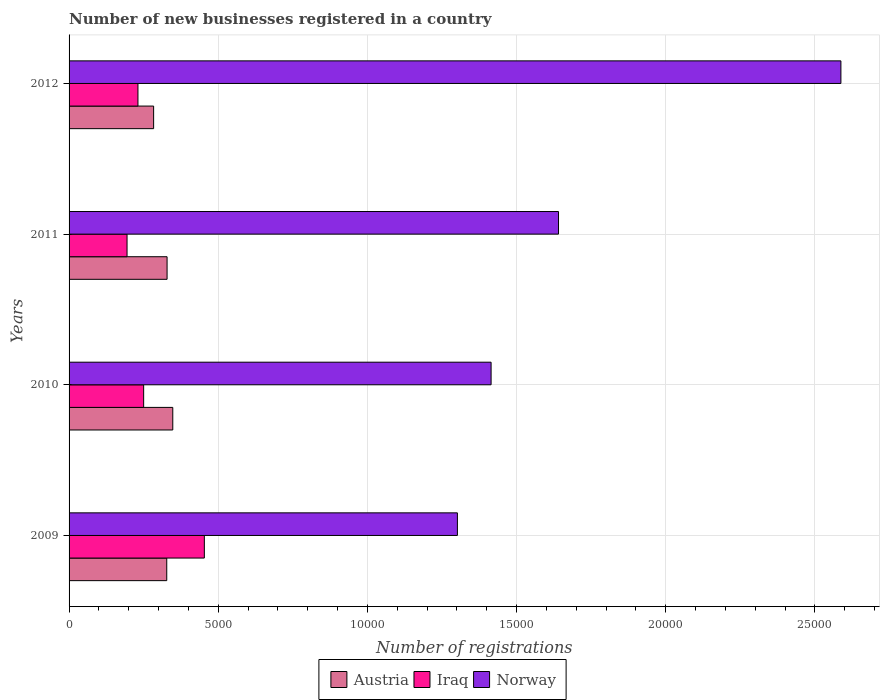How many different coloured bars are there?
Provide a succinct answer. 3. How many groups of bars are there?
Your answer should be compact. 4. Are the number of bars per tick equal to the number of legend labels?
Offer a very short reply. Yes. How many bars are there on the 4th tick from the top?
Make the answer very short. 3. How many bars are there on the 2nd tick from the bottom?
Keep it short and to the point. 3. What is the number of new businesses registered in Norway in 2010?
Your answer should be very brief. 1.41e+04. Across all years, what is the maximum number of new businesses registered in Norway?
Give a very brief answer. 2.59e+04. Across all years, what is the minimum number of new businesses registered in Norway?
Offer a terse response. 1.30e+04. In which year was the number of new businesses registered in Austria minimum?
Your response must be concise. 2012. What is the total number of new businesses registered in Iraq in the graph?
Provide a succinct answer. 1.13e+04. What is the difference between the number of new businesses registered in Iraq in 2009 and that in 2012?
Offer a terse response. 2225. What is the difference between the number of new businesses registered in Norway in 2010 and the number of new businesses registered in Iraq in 2009?
Make the answer very short. 9611. What is the average number of new businesses registered in Norway per year?
Make the answer very short. 1.74e+04. In the year 2009, what is the difference between the number of new businesses registered in Austria and number of new businesses registered in Iraq?
Provide a succinct answer. -1260. In how many years, is the number of new businesses registered in Iraq greater than 2000 ?
Provide a succinct answer. 3. What is the ratio of the number of new businesses registered in Norway in 2009 to that in 2012?
Offer a very short reply. 0.5. What is the difference between the highest and the second highest number of new businesses registered in Iraq?
Keep it short and to the point. 2034. What is the difference between the highest and the lowest number of new businesses registered in Norway?
Your answer should be compact. 1.29e+04. In how many years, is the number of new businesses registered in Norway greater than the average number of new businesses registered in Norway taken over all years?
Your answer should be very brief. 1. Is the sum of the number of new businesses registered in Iraq in 2010 and 2011 greater than the maximum number of new businesses registered in Austria across all years?
Your response must be concise. Yes. What does the 3rd bar from the top in 2012 represents?
Your response must be concise. Austria. What is the difference between two consecutive major ticks on the X-axis?
Your answer should be very brief. 5000. Are the values on the major ticks of X-axis written in scientific E-notation?
Ensure brevity in your answer.  No. Does the graph contain any zero values?
Your answer should be very brief. No. Where does the legend appear in the graph?
Your answer should be compact. Bottom center. How are the legend labels stacked?
Give a very brief answer. Horizontal. What is the title of the graph?
Offer a terse response. Number of new businesses registered in a country. Does "Sudan" appear as one of the legend labels in the graph?
Your answer should be compact. No. What is the label or title of the X-axis?
Offer a very short reply. Number of registrations. What is the label or title of the Y-axis?
Ensure brevity in your answer.  Years. What is the Number of registrations in Austria in 2009?
Provide a succinct answer. 3274. What is the Number of registrations in Iraq in 2009?
Your answer should be compact. 4534. What is the Number of registrations in Norway in 2009?
Keep it short and to the point. 1.30e+04. What is the Number of registrations in Austria in 2010?
Your response must be concise. 3476. What is the Number of registrations in Iraq in 2010?
Give a very brief answer. 2500. What is the Number of registrations of Norway in 2010?
Ensure brevity in your answer.  1.41e+04. What is the Number of registrations of Austria in 2011?
Your response must be concise. 3285. What is the Number of registrations in Iraq in 2011?
Provide a short and direct response. 1943. What is the Number of registrations in Norway in 2011?
Keep it short and to the point. 1.64e+04. What is the Number of registrations in Austria in 2012?
Provide a succinct answer. 2834. What is the Number of registrations in Iraq in 2012?
Keep it short and to the point. 2309. What is the Number of registrations of Norway in 2012?
Offer a terse response. 2.59e+04. Across all years, what is the maximum Number of registrations of Austria?
Your answer should be compact. 3476. Across all years, what is the maximum Number of registrations of Iraq?
Ensure brevity in your answer.  4534. Across all years, what is the maximum Number of registrations of Norway?
Keep it short and to the point. 2.59e+04. Across all years, what is the minimum Number of registrations of Austria?
Provide a succinct answer. 2834. Across all years, what is the minimum Number of registrations of Iraq?
Offer a very short reply. 1943. Across all years, what is the minimum Number of registrations of Norway?
Offer a terse response. 1.30e+04. What is the total Number of registrations in Austria in the graph?
Your response must be concise. 1.29e+04. What is the total Number of registrations in Iraq in the graph?
Make the answer very short. 1.13e+04. What is the total Number of registrations in Norway in the graph?
Offer a terse response. 6.94e+04. What is the difference between the Number of registrations of Austria in 2009 and that in 2010?
Offer a very short reply. -202. What is the difference between the Number of registrations of Iraq in 2009 and that in 2010?
Give a very brief answer. 2034. What is the difference between the Number of registrations in Norway in 2009 and that in 2010?
Give a very brief answer. -1129. What is the difference between the Number of registrations in Austria in 2009 and that in 2011?
Make the answer very short. -11. What is the difference between the Number of registrations of Iraq in 2009 and that in 2011?
Your answer should be compact. 2591. What is the difference between the Number of registrations of Norway in 2009 and that in 2011?
Provide a short and direct response. -3389. What is the difference between the Number of registrations in Austria in 2009 and that in 2012?
Make the answer very short. 440. What is the difference between the Number of registrations of Iraq in 2009 and that in 2012?
Keep it short and to the point. 2225. What is the difference between the Number of registrations of Norway in 2009 and that in 2012?
Offer a very short reply. -1.29e+04. What is the difference between the Number of registrations of Austria in 2010 and that in 2011?
Your answer should be compact. 191. What is the difference between the Number of registrations of Iraq in 2010 and that in 2011?
Your response must be concise. 557. What is the difference between the Number of registrations of Norway in 2010 and that in 2011?
Keep it short and to the point. -2260. What is the difference between the Number of registrations in Austria in 2010 and that in 2012?
Offer a terse response. 642. What is the difference between the Number of registrations of Iraq in 2010 and that in 2012?
Your answer should be compact. 191. What is the difference between the Number of registrations in Norway in 2010 and that in 2012?
Your answer should be compact. -1.17e+04. What is the difference between the Number of registrations of Austria in 2011 and that in 2012?
Give a very brief answer. 451. What is the difference between the Number of registrations of Iraq in 2011 and that in 2012?
Offer a very short reply. -366. What is the difference between the Number of registrations in Norway in 2011 and that in 2012?
Make the answer very short. -9465. What is the difference between the Number of registrations of Austria in 2009 and the Number of registrations of Iraq in 2010?
Your answer should be very brief. 774. What is the difference between the Number of registrations of Austria in 2009 and the Number of registrations of Norway in 2010?
Your response must be concise. -1.09e+04. What is the difference between the Number of registrations in Iraq in 2009 and the Number of registrations in Norway in 2010?
Provide a short and direct response. -9611. What is the difference between the Number of registrations of Austria in 2009 and the Number of registrations of Iraq in 2011?
Your answer should be very brief. 1331. What is the difference between the Number of registrations in Austria in 2009 and the Number of registrations in Norway in 2011?
Keep it short and to the point. -1.31e+04. What is the difference between the Number of registrations in Iraq in 2009 and the Number of registrations in Norway in 2011?
Your answer should be compact. -1.19e+04. What is the difference between the Number of registrations in Austria in 2009 and the Number of registrations in Iraq in 2012?
Ensure brevity in your answer.  965. What is the difference between the Number of registrations of Austria in 2009 and the Number of registrations of Norway in 2012?
Your answer should be compact. -2.26e+04. What is the difference between the Number of registrations of Iraq in 2009 and the Number of registrations of Norway in 2012?
Your response must be concise. -2.13e+04. What is the difference between the Number of registrations of Austria in 2010 and the Number of registrations of Iraq in 2011?
Provide a succinct answer. 1533. What is the difference between the Number of registrations in Austria in 2010 and the Number of registrations in Norway in 2011?
Provide a succinct answer. -1.29e+04. What is the difference between the Number of registrations in Iraq in 2010 and the Number of registrations in Norway in 2011?
Offer a terse response. -1.39e+04. What is the difference between the Number of registrations of Austria in 2010 and the Number of registrations of Iraq in 2012?
Offer a terse response. 1167. What is the difference between the Number of registrations of Austria in 2010 and the Number of registrations of Norway in 2012?
Make the answer very short. -2.24e+04. What is the difference between the Number of registrations of Iraq in 2010 and the Number of registrations of Norway in 2012?
Give a very brief answer. -2.34e+04. What is the difference between the Number of registrations of Austria in 2011 and the Number of registrations of Iraq in 2012?
Offer a terse response. 976. What is the difference between the Number of registrations of Austria in 2011 and the Number of registrations of Norway in 2012?
Your answer should be very brief. -2.26e+04. What is the difference between the Number of registrations of Iraq in 2011 and the Number of registrations of Norway in 2012?
Offer a terse response. -2.39e+04. What is the average Number of registrations of Austria per year?
Your answer should be very brief. 3217.25. What is the average Number of registrations of Iraq per year?
Ensure brevity in your answer.  2821.5. What is the average Number of registrations in Norway per year?
Provide a succinct answer. 1.74e+04. In the year 2009, what is the difference between the Number of registrations in Austria and Number of registrations in Iraq?
Offer a terse response. -1260. In the year 2009, what is the difference between the Number of registrations of Austria and Number of registrations of Norway?
Offer a very short reply. -9742. In the year 2009, what is the difference between the Number of registrations of Iraq and Number of registrations of Norway?
Your answer should be compact. -8482. In the year 2010, what is the difference between the Number of registrations of Austria and Number of registrations of Iraq?
Keep it short and to the point. 976. In the year 2010, what is the difference between the Number of registrations of Austria and Number of registrations of Norway?
Provide a succinct answer. -1.07e+04. In the year 2010, what is the difference between the Number of registrations in Iraq and Number of registrations in Norway?
Keep it short and to the point. -1.16e+04. In the year 2011, what is the difference between the Number of registrations in Austria and Number of registrations in Iraq?
Your answer should be very brief. 1342. In the year 2011, what is the difference between the Number of registrations in Austria and Number of registrations in Norway?
Offer a very short reply. -1.31e+04. In the year 2011, what is the difference between the Number of registrations of Iraq and Number of registrations of Norway?
Offer a very short reply. -1.45e+04. In the year 2012, what is the difference between the Number of registrations in Austria and Number of registrations in Iraq?
Your response must be concise. 525. In the year 2012, what is the difference between the Number of registrations of Austria and Number of registrations of Norway?
Offer a very short reply. -2.30e+04. In the year 2012, what is the difference between the Number of registrations of Iraq and Number of registrations of Norway?
Offer a very short reply. -2.36e+04. What is the ratio of the Number of registrations of Austria in 2009 to that in 2010?
Make the answer very short. 0.94. What is the ratio of the Number of registrations of Iraq in 2009 to that in 2010?
Offer a very short reply. 1.81. What is the ratio of the Number of registrations of Norway in 2009 to that in 2010?
Offer a terse response. 0.92. What is the ratio of the Number of registrations of Austria in 2009 to that in 2011?
Provide a short and direct response. 1. What is the ratio of the Number of registrations of Iraq in 2009 to that in 2011?
Provide a succinct answer. 2.33. What is the ratio of the Number of registrations of Norway in 2009 to that in 2011?
Keep it short and to the point. 0.79. What is the ratio of the Number of registrations in Austria in 2009 to that in 2012?
Your answer should be compact. 1.16. What is the ratio of the Number of registrations of Iraq in 2009 to that in 2012?
Make the answer very short. 1.96. What is the ratio of the Number of registrations in Norway in 2009 to that in 2012?
Ensure brevity in your answer.  0.5. What is the ratio of the Number of registrations of Austria in 2010 to that in 2011?
Your response must be concise. 1.06. What is the ratio of the Number of registrations in Iraq in 2010 to that in 2011?
Offer a very short reply. 1.29. What is the ratio of the Number of registrations in Norway in 2010 to that in 2011?
Offer a very short reply. 0.86. What is the ratio of the Number of registrations in Austria in 2010 to that in 2012?
Your response must be concise. 1.23. What is the ratio of the Number of registrations in Iraq in 2010 to that in 2012?
Offer a very short reply. 1.08. What is the ratio of the Number of registrations of Norway in 2010 to that in 2012?
Offer a very short reply. 0.55. What is the ratio of the Number of registrations of Austria in 2011 to that in 2012?
Keep it short and to the point. 1.16. What is the ratio of the Number of registrations of Iraq in 2011 to that in 2012?
Make the answer very short. 0.84. What is the ratio of the Number of registrations of Norway in 2011 to that in 2012?
Your answer should be very brief. 0.63. What is the difference between the highest and the second highest Number of registrations of Austria?
Provide a succinct answer. 191. What is the difference between the highest and the second highest Number of registrations of Iraq?
Your answer should be very brief. 2034. What is the difference between the highest and the second highest Number of registrations of Norway?
Your answer should be very brief. 9465. What is the difference between the highest and the lowest Number of registrations in Austria?
Provide a succinct answer. 642. What is the difference between the highest and the lowest Number of registrations in Iraq?
Offer a very short reply. 2591. What is the difference between the highest and the lowest Number of registrations of Norway?
Your answer should be very brief. 1.29e+04. 